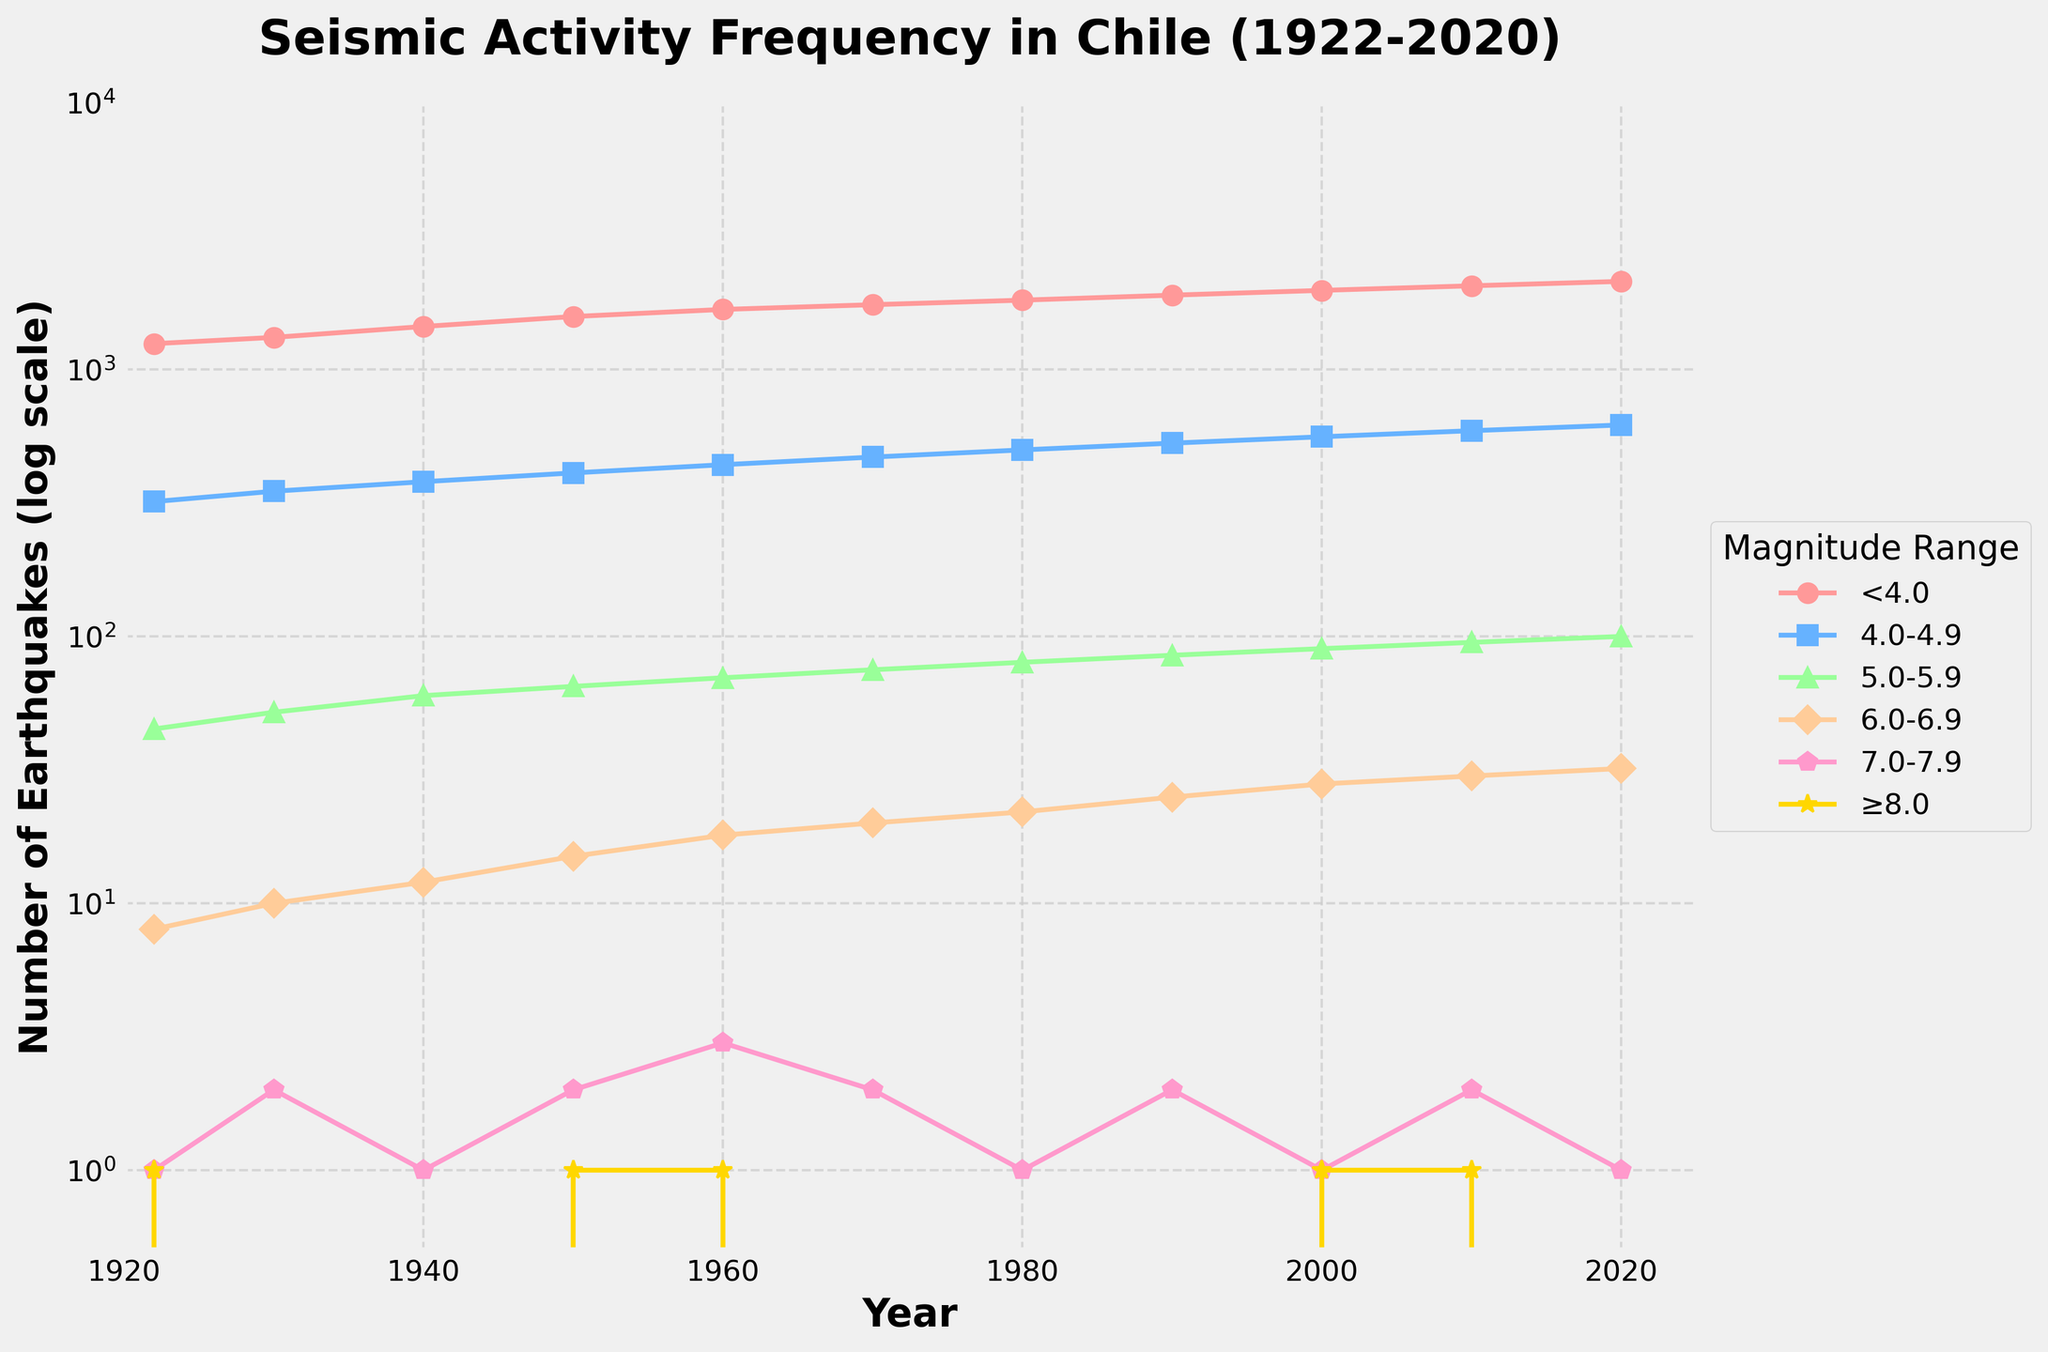What was the frequency of earthquakes with magnitudes between 5.0 and 5.9 in 2000? Locate the line representing the 5.0-5.9 magnitude range by its shape and color, and follow it to the year 2000 on the x-axis. The corresponding y-value is the frequency.
Answer: 90 How do the frequencies of earthquakes with magnitudes less than 4.0 in 1922 compare to those in 2020? Look for the lines representing '<4.0' magnitude earthquakes in 1922 and 2020. Compare the y-values directly.
Answer: Higher in 2020 What is the total frequency of earthquakes for the year 1950 across all magnitude ranges? Sum the frequencies for each magnitude range in the year 1950: 1580 + 410 + 65 + 15 + 2 + 1.
Answer: 2073 Which magnitude range had the highest increase in frequency from 1922 to 2020? Compare the differences between the frequencies in 1922 and 2020 for each magnitude range and identify the greatest increase: (frequency_2020 - frequency_1922).
Answer: < 4.0 What is the trend in the frequency of earthquakes with magnitudes ≥8.0 over the decades shown? Observe the shape and direction of the line representing ≥8.0 earthquakes across the years. Note the changes (increase, decrease, or stable) over time.
Answer: Generally stable In which year did earthquakes with magnitudes 6.0-6.9 peak? Follow the line for 6.0-6.9 earthquakes and locate the maximum y-value, noting the corresponding year on the x-axis.
Answer: 2020 Which magnitude range had the least variation in its frequency over the observed period? Compare the overall changes in frequency for each magnitude range over the timeline, focusing on the range that stays most consistent across years.
Answer: ≥8.0 What is the average frequency of earthquakes with magnitudes between 4.0 and 4.9 over the entire period? Sum the frequencies for 4.0-4.9 earthquakes for all years and divide by the number of years (11): (320 + 350 + 380 + 410 + 440 + 470 + 500 + 530 + 560 + 590 + 620) / 11.
Answer: 471 How many more earthquakes with magnitudes ≥7.0 were recorded in 1960 compared to 1980? Subtract the frequency of ≥7.0 earthquakes in 1980 from that in 1960: (3+1) - (1+0).
Answer: 3 more 